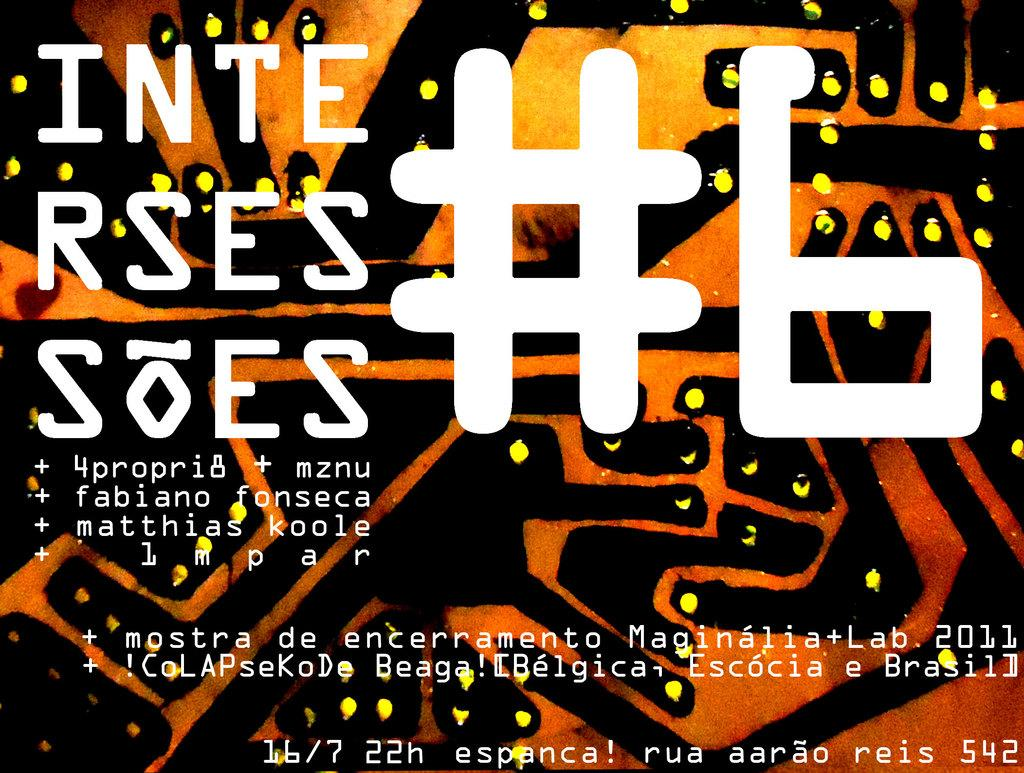<image>
Give a short and clear explanation of the subsequent image. A sign has the following in white: inte rses #6. 